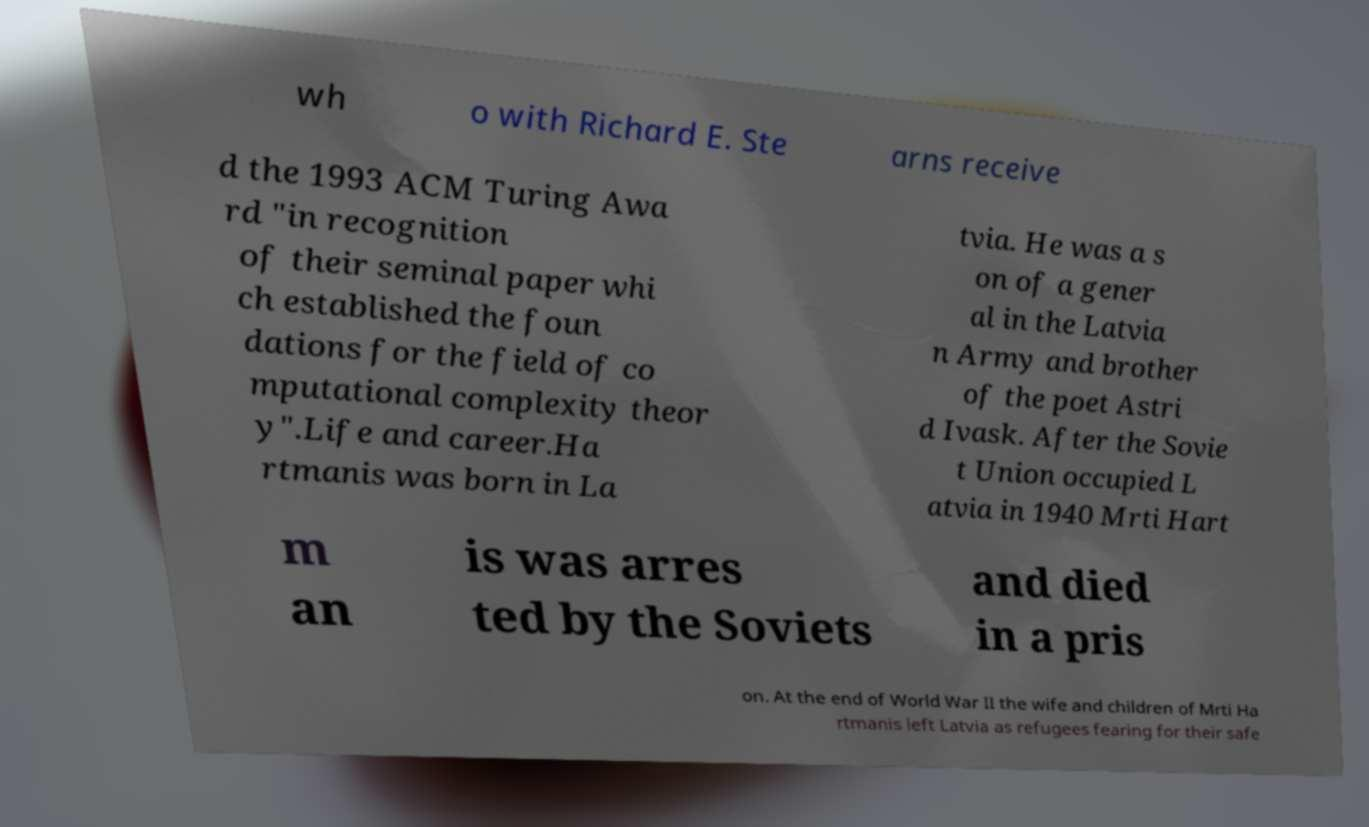Can you read and provide the text displayed in the image?This photo seems to have some interesting text. Can you extract and type it out for me? wh o with Richard E. Ste arns receive d the 1993 ACM Turing Awa rd "in recognition of their seminal paper whi ch established the foun dations for the field of co mputational complexity theor y".Life and career.Ha rtmanis was born in La tvia. He was a s on of a gener al in the Latvia n Army and brother of the poet Astri d Ivask. After the Sovie t Union occupied L atvia in 1940 Mrti Hart m an is was arres ted by the Soviets and died in a pris on. At the end of World War II the wife and children of Mrti Ha rtmanis left Latvia as refugees fearing for their safe 